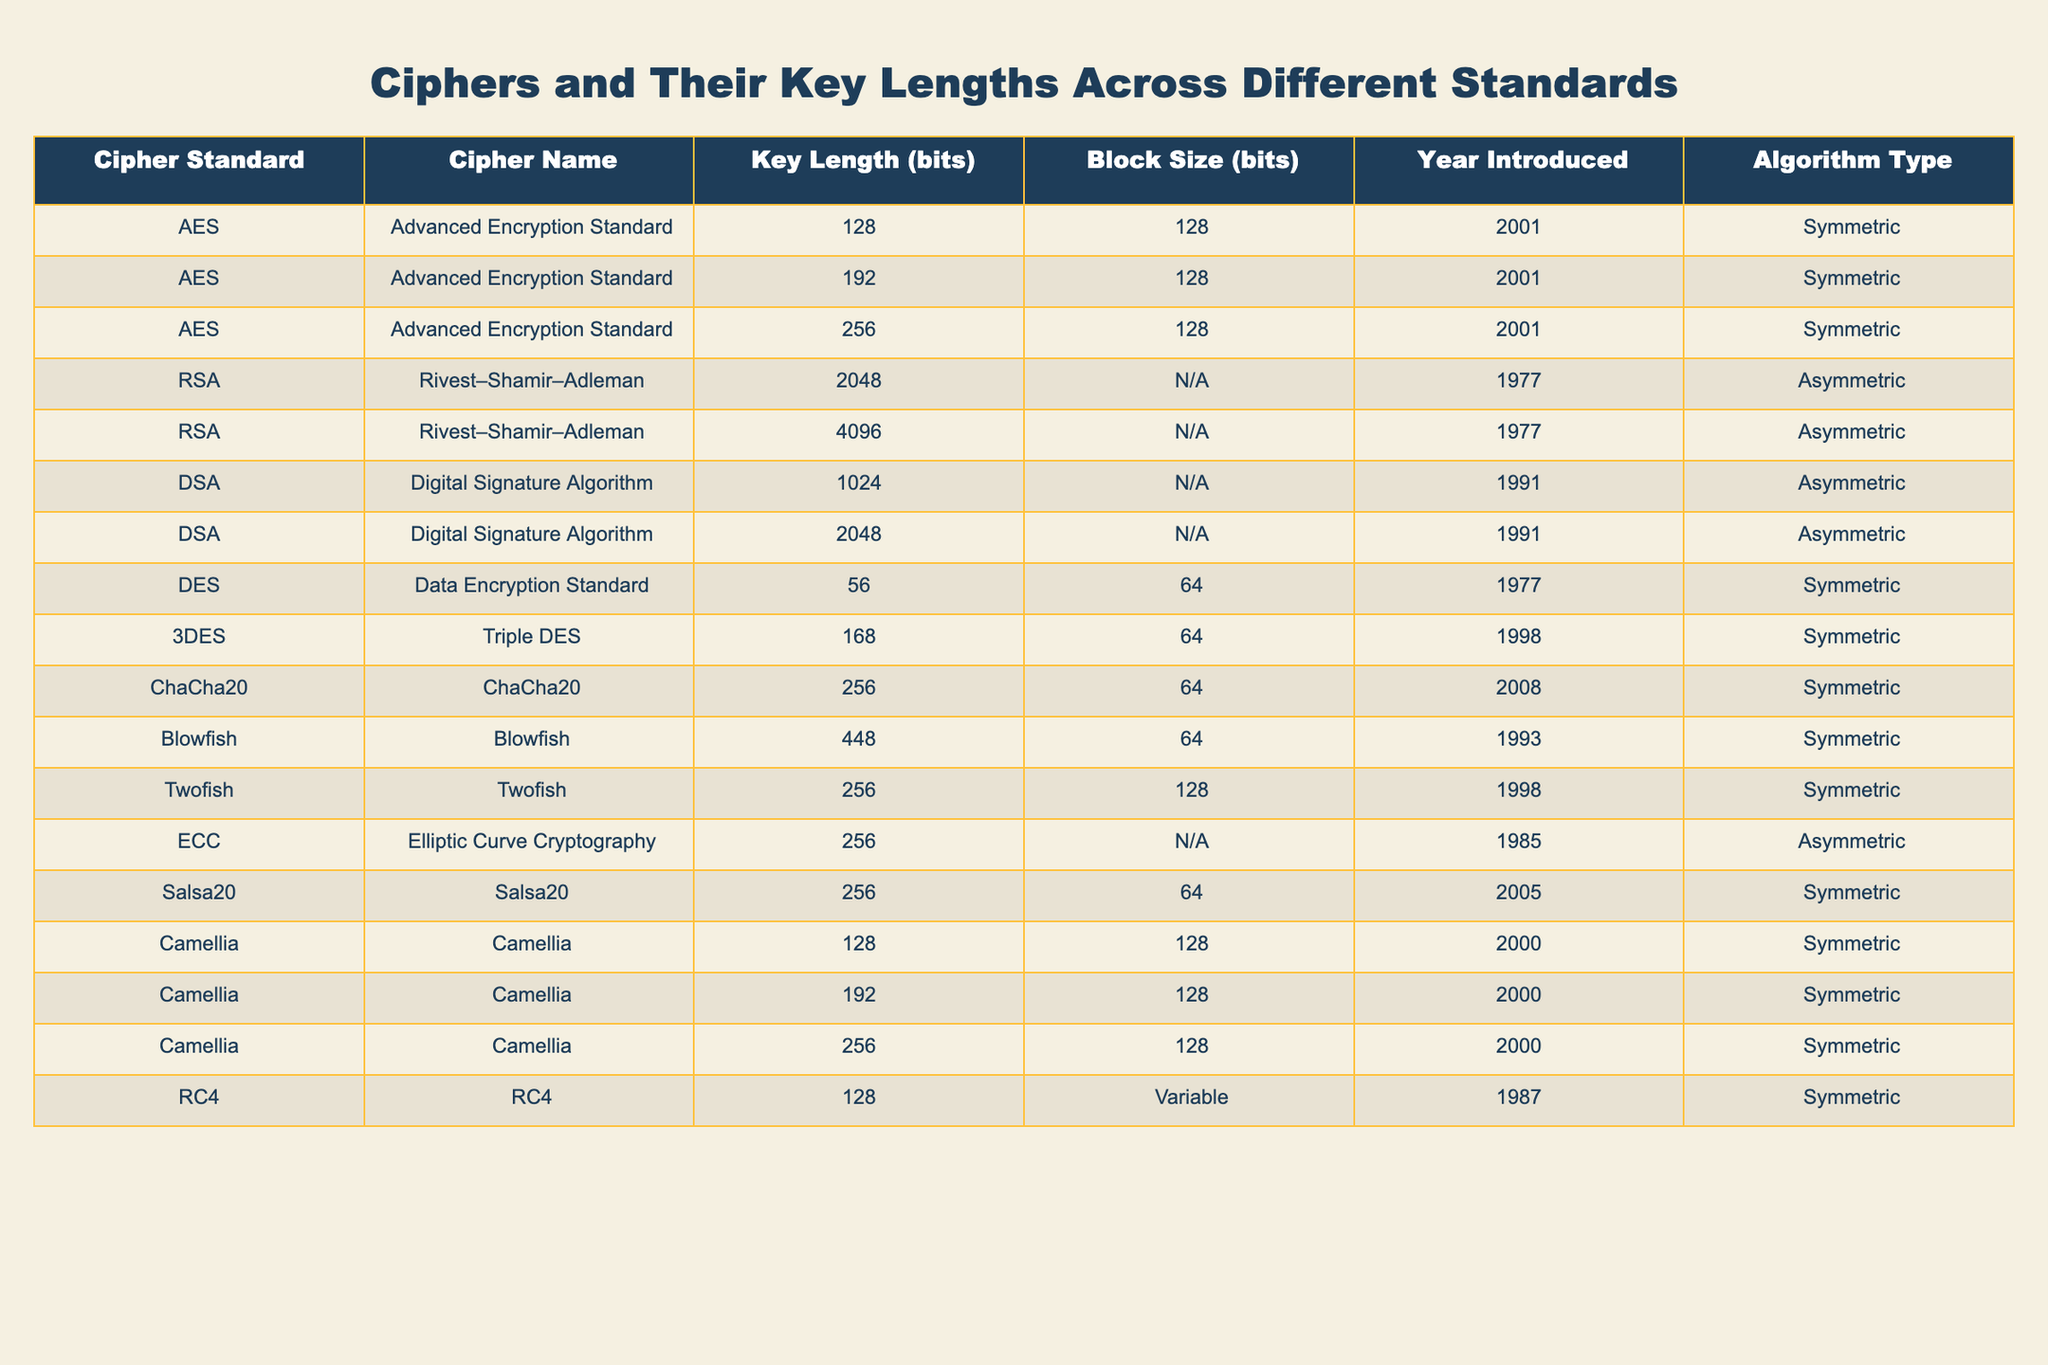What is the key length of the AES standard? The table lists the key lengths for the AES standard as 128, 192, and 256 bits.
Answer: 128, 192, and 256 bits What is the year when RSA was introduced? The table shows that RSA was introduced in the year 1977.
Answer: 1977 Which cipher has the longest key length? Among the ciphers listed, Blowfish has the longest key length of 448 bits.
Answer: 448 bits How many asymmetric algorithms are mentioned in the table? The table includes three asymmetric algorithms: RSA, DSA, and ECC, giving a total of three.
Answer: 3 Is the block size for ChaCha20 specified in the table? The table indicates that the block size for ChaCha20 is 64 bits.
Answer: Yes What is the average key length of the symmetric algorithms listed? The key lengths for symmetric algorithms in the table are 128, 192, 256, 56, 168, 448, 256, 128, and 256. There are 9 symmetric keys. The sum is (128 + 192 + 256 + 56 + 168 + 448 + 256 + 128 + 256) = 1924, hence the average is 1924/9 ≈ 213.78.
Answer: Approximately 213.78 bits What is the block size for the RSA standard? The table does not specify a block size for RSA, indicating it as N/A.
Answer: N/A Did the DSA standard have its key lengths increasing over the years? The DSA has key lengths of 1024 and 2048 bits introduced in 1991, showing an increase in key length.
Answer: Yes Which cipher has the same key length but different standards? Both AES and Camellia have the same key length of 128 bits and are symmetric ciphers, while RSA and ECC are asymmetric.
Answer: AES and Camellia What is the relationship between key length and year introduced for RSA? RSA was introduced in 1977 with key lengths of 2048 and 4096 bits, showing that its key lengths were significantly large from the start.
Answer: Longer key lengths introduced in 1977 How many ciphers have a key length of 256 bits? The table lists three ciphers with a key length of 256 bits: AES, Twofish, and ChaCha20.
Answer: 3 